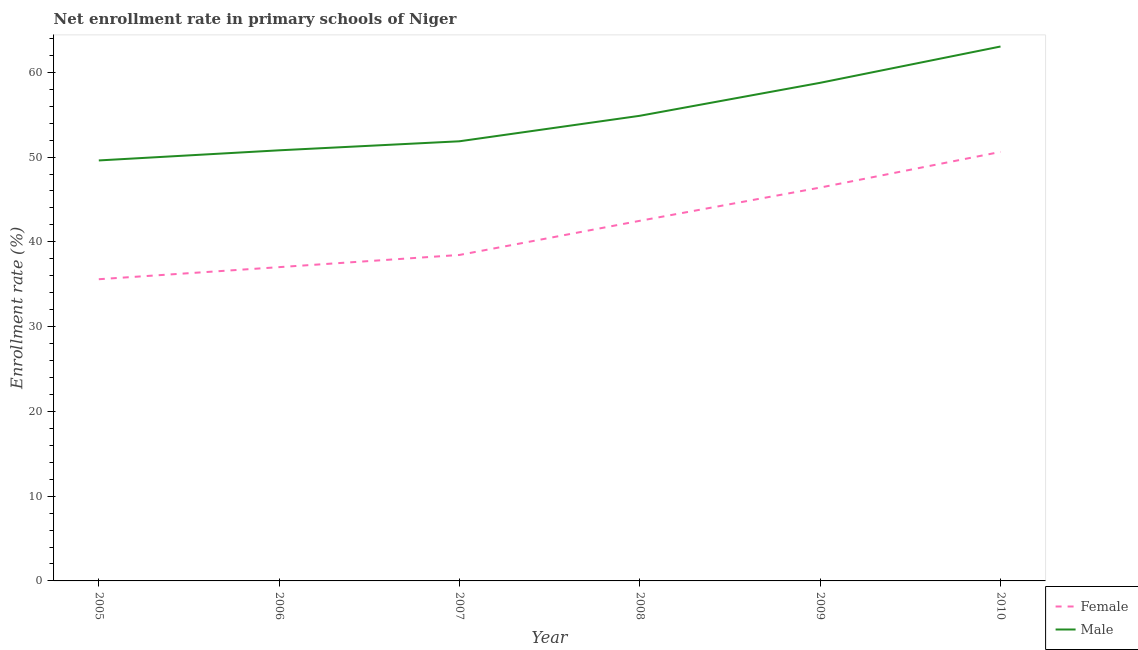What is the enrollment rate of female students in 2006?
Provide a short and direct response. 37.02. Across all years, what is the maximum enrollment rate of male students?
Ensure brevity in your answer.  63.04. Across all years, what is the minimum enrollment rate of male students?
Your answer should be compact. 49.6. What is the total enrollment rate of male students in the graph?
Make the answer very short. 328.95. What is the difference between the enrollment rate of female students in 2005 and that in 2007?
Your answer should be compact. -2.86. What is the difference between the enrollment rate of male students in 2007 and the enrollment rate of female students in 2010?
Keep it short and to the point. 1.25. What is the average enrollment rate of male students per year?
Provide a succinct answer. 54.82. In the year 2006, what is the difference between the enrollment rate of male students and enrollment rate of female students?
Ensure brevity in your answer.  13.78. What is the ratio of the enrollment rate of male students in 2006 to that in 2010?
Ensure brevity in your answer.  0.81. Is the enrollment rate of male students in 2005 less than that in 2010?
Make the answer very short. Yes. What is the difference between the highest and the second highest enrollment rate of female students?
Offer a terse response. 4.21. What is the difference between the highest and the lowest enrollment rate of female students?
Ensure brevity in your answer.  15.02. In how many years, is the enrollment rate of female students greater than the average enrollment rate of female students taken over all years?
Your answer should be very brief. 3. Is the sum of the enrollment rate of male students in 2006 and 2008 greater than the maximum enrollment rate of female students across all years?
Make the answer very short. Yes. Does the enrollment rate of female students monotonically increase over the years?
Your response must be concise. Yes. Is the enrollment rate of male students strictly greater than the enrollment rate of female students over the years?
Offer a terse response. Yes. How many lines are there?
Provide a short and direct response. 2. What is the difference between two consecutive major ticks on the Y-axis?
Your answer should be compact. 10. Does the graph contain any zero values?
Keep it short and to the point. No. Does the graph contain grids?
Provide a short and direct response. No. What is the title of the graph?
Your answer should be very brief. Net enrollment rate in primary schools of Niger. What is the label or title of the X-axis?
Keep it short and to the point. Year. What is the label or title of the Y-axis?
Provide a short and direct response. Enrollment rate (%). What is the Enrollment rate (%) of Female in 2005?
Your answer should be compact. 35.59. What is the Enrollment rate (%) of Male in 2005?
Your answer should be compact. 49.6. What is the Enrollment rate (%) in Female in 2006?
Provide a short and direct response. 37.02. What is the Enrollment rate (%) of Male in 2006?
Your response must be concise. 50.8. What is the Enrollment rate (%) in Female in 2007?
Offer a very short reply. 38.46. What is the Enrollment rate (%) of Male in 2007?
Provide a short and direct response. 51.87. What is the Enrollment rate (%) of Female in 2008?
Offer a terse response. 42.48. What is the Enrollment rate (%) of Male in 2008?
Offer a very short reply. 54.87. What is the Enrollment rate (%) of Female in 2009?
Your response must be concise. 46.4. What is the Enrollment rate (%) in Male in 2009?
Ensure brevity in your answer.  58.76. What is the Enrollment rate (%) of Female in 2010?
Provide a short and direct response. 50.61. What is the Enrollment rate (%) of Male in 2010?
Your answer should be very brief. 63.04. Across all years, what is the maximum Enrollment rate (%) in Female?
Offer a very short reply. 50.61. Across all years, what is the maximum Enrollment rate (%) of Male?
Provide a succinct answer. 63.04. Across all years, what is the minimum Enrollment rate (%) of Female?
Offer a very short reply. 35.59. Across all years, what is the minimum Enrollment rate (%) in Male?
Provide a succinct answer. 49.6. What is the total Enrollment rate (%) in Female in the graph?
Provide a short and direct response. 250.56. What is the total Enrollment rate (%) of Male in the graph?
Keep it short and to the point. 328.95. What is the difference between the Enrollment rate (%) of Female in 2005 and that in 2006?
Ensure brevity in your answer.  -1.43. What is the difference between the Enrollment rate (%) of Male in 2005 and that in 2006?
Offer a very short reply. -1.19. What is the difference between the Enrollment rate (%) in Female in 2005 and that in 2007?
Provide a succinct answer. -2.86. What is the difference between the Enrollment rate (%) of Male in 2005 and that in 2007?
Ensure brevity in your answer.  -2.26. What is the difference between the Enrollment rate (%) in Female in 2005 and that in 2008?
Your answer should be compact. -6.89. What is the difference between the Enrollment rate (%) in Male in 2005 and that in 2008?
Offer a terse response. -5.27. What is the difference between the Enrollment rate (%) of Female in 2005 and that in 2009?
Ensure brevity in your answer.  -10.81. What is the difference between the Enrollment rate (%) in Male in 2005 and that in 2009?
Your answer should be compact. -9.16. What is the difference between the Enrollment rate (%) in Female in 2005 and that in 2010?
Offer a very short reply. -15.02. What is the difference between the Enrollment rate (%) of Male in 2005 and that in 2010?
Give a very brief answer. -13.44. What is the difference between the Enrollment rate (%) of Female in 2006 and that in 2007?
Your response must be concise. -1.44. What is the difference between the Enrollment rate (%) in Male in 2006 and that in 2007?
Keep it short and to the point. -1.07. What is the difference between the Enrollment rate (%) of Female in 2006 and that in 2008?
Offer a terse response. -5.47. What is the difference between the Enrollment rate (%) of Male in 2006 and that in 2008?
Provide a short and direct response. -4.07. What is the difference between the Enrollment rate (%) of Female in 2006 and that in 2009?
Your answer should be compact. -9.39. What is the difference between the Enrollment rate (%) in Male in 2006 and that in 2009?
Your answer should be very brief. -7.96. What is the difference between the Enrollment rate (%) in Female in 2006 and that in 2010?
Provide a succinct answer. -13.59. What is the difference between the Enrollment rate (%) of Male in 2006 and that in 2010?
Offer a terse response. -12.25. What is the difference between the Enrollment rate (%) of Female in 2007 and that in 2008?
Offer a very short reply. -4.03. What is the difference between the Enrollment rate (%) of Male in 2007 and that in 2008?
Offer a terse response. -3.01. What is the difference between the Enrollment rate (%) in Female in 2007 and that in 2009?
Provide a succinct answer. -7.95. What is the difference between the Enrollment rate (%) in Male in 2007 and that in 2009?
Provide a succinct answer. -6.9. What is the difference between the Enrollment rate (%) in Female in 2007 and that in 2010?
Offer a terse response. -12.16. What is the difference between the Enrollment rate (%) of Male in 2007 and that in 2010?
Make the answer very short. -11.18. What is the difference between the Enrollment rate (%) of Female in 2008 and that in 2009?
Ensure brevity in your answer.  -3.92. What is the difference between the Enrollment rate (%) of Male in 2008 and that in 2009?
Your answer should be very brief. -3.89. What is the difference between the Enrollment rate (%) in Female in 2008 and that in 2010?
Make the answer very short. -8.13. What is the difference between the Enrollment rate (%) of Male in 2008 and that in 2010?
Offer a terse response. -8.17. What is the difference between the Enrollment rate (%) in Female in 2009 and that in 2010?
Make the answer very short. -4.21. What is the difference between the Enrollment rate (%) in Male in 2009 and that in 2010?
Keep it short and to the point. -4.28. What is the difference between the Enrollment rate (%) in Female in 2005 and the Enrollment rate (%) in Male in 2006?
Your response must be concise. -15.21. What is the difference between the Enrollment rate (%) in Female in 2005 and the Enrollment rate (%) in Male in 2007?
Provide a succinct answer. -16.27. What is the difference between the Enrollment rate (%) in Female in 2005 and the Enrollment rate (%) in Male in 2008?
Make the answer very short. -19.28. What is the difference between the Enrollment rate (%) of Female in 2005 and the Enrollment rate (%) of Male in 2009?
Your answer should be very brief. -23.17. What is the difference between the Enrollment rate (%) in Female in 2005 and the Enrollment rate (%) in Male in 2010?
Provide a short and direct response. -27.45. What is the difference between the Enrollment rate (%) of Female in 2006 and the Enrollment rate (%) of Male in 2007?
Offer a very short reply. -14.85. What is the difference between the Enrollment rate (%) in Female in 2006 and the Enrollment rate (%) in Male in 2008?
Offer a terse response. -17.86. What is the difference between the Enrollment rate (%) of Female in 2006 and the Enrollment rate (%) of Male in 2009?
Provide a succinct answer. -21.74. What is the difference between the Enrollment rate (%) in Female in 2006 and the Enrollment rate (%) in Male in 2010?
Provide a short and direct response. -26.03. What is the difference between the Enrollment rate (%) in Female in 2007 and the Enrollment rate (%) in Male in 2008?
Keep it short and to the point. -16.42. What is the difference between the Enrollment rate (%) of Female in 2007 and the Enrollment rate (%) of Male in 2009?
Offer a terse response. -20.31. What is the difference between the Enrollment rate (%) of Female in 2007 and the Enrollment rate (%) of Male in 2010?
Your answer should be compact. -24.59. What is the difference between the Enrollment rate (%) in Female in 2008 and the Enrollment rate (%) in Male in 2009?
Keep it short and to the point. -16.28. What is the difference between the Enrollment rate (%) of Female in 2008 and the Enrollment rate (%) of Male in 2010?
Keep it short and to the point. -20.56. What is the difference between the Enrollment rate (%) in Female in 2009 and the Enrollment rate (%) in Male in 2010?
Provide a short and direct response. -16.64. What is the average Enrollment rate (%) in Female per year?
Make the answer very short. 41.76. What is the average Enrollment rate (%) in Male per year?
Offer a terse response. 54.82. In the year 2005, what is the difference between the Enrollment rate (%) of Female and Enrollment rate (%) of Male?
Your answer should be compact. -14.01. In the year 2006, what is the difference between the Enrollment rate (%) of Female and Enrollment rate (%) of Male?
Ensure brevity in your answer.  -13.78. In the year 2007, what is the difference between the Enrollment rate (%) of Female and Enrollment rate (%) of Male?
Offer a very short reply. -13.41. In the year 2008, what is the difference between the Enrollment rate (%) in Female and Enrollment rate (%) in Male?
Give a very brief answer. -12.39. In the year 2009, what is the difference between the Enrollment rate (%) of Female and Enrollment rate (%) of Male?
Give a very brief answer. -12.36. In the year 2010, what is the difference between the Enrollment rate (%) of Female and Enrollment rate (%) of Male?
Give a very brief answer. -12.43. What is the ratio of the Enrollment rate (%) in Female in 2005 to that in 2006?
Your answer should be very brief. 0.96. What is the ratio of the Enrollment rate (%) in Male in 2005 to that in 2006?
Your response must be concise. 0.98. What is the ratio of the Enrollment rate (%) of Female in 2005 to that in 2007?
Your answer should be very brief. 0.93. What is the ratio of the Enrollment rate (%) in Male in 2005 to that in 2007?
Make the answer very short. 0.96. What is the ratio of the Enrollment rate (%) in Female in 2005 to that in 2008?
Give a very brief answer. 0.84. What is the ratio of the Enrollment rate (%) of Male in 2005 to that in 2008?
Give a very brief answer. 0.9. What is the ratio of the Enrollment rate (%) in Female in 2005 to that in 2009?
Ensure brevity in your answer.  0.77. What is the ratio of the Enrollment rate (%) in Male in 2005 to that in 2009?
Give a very brief answer. 0.84. What is the ratio of the Enrollment rate (%) in Female in 2005 to that in 2010?
Give a very brief answer. 0.7. What is the ratio of the Enrollment rate (%) in Male in 2005 to that in 2010?
Your answer should be very brief. 0.79. What is the ratio of the Enrollment rate (%) in Female in 2006 to that in 2007?
Your response must be concise. 0.96. What is the ratio of the Enrollment rate (%) of Male in 2006 to that in 2007?
Your answer should be very brief. 0.98. What is the ratio of the Enrollment rate (%) of Female in 2006 to that in 2008?
Provide a short and direct response. 0.87. What is the ratio of the Enrollment rate (%) of Male in 2006 to that in 2008?
Your response must be concise. 0.93. What is the ratio of the Enrollment rate (%) in Female in 2006 to that in 2009?
Make the answer very short. 0.8. What is the ratio of the Enrollment rate (%) in Male in 2006 to that in 2009?
Make the answer very short. 0.86. What is the ratio of the Enrollment rate (%) in Female in 2006 to that in 2010?
Give a very brief answer. 0.73. What is the ratio of the Enrollment rate (%) in Male in 2006 to that in 2010?
Your answer should be very brief. 0.81. What is the ratio of the Enrollment rate (%) of Female in 2007 to that in 2008?
Offer a terse response. 0.91. What is the ratio of the Enrollment rate (%) of Male in 2007 to that in 2008?
Provide a succinct answer. 0.95. What is the ratio of the Enrollment rate (%) in Female in 2007 to that in 2009?
Offer a terse response. 0.83. What is the ratio of the Enrollment rate (%) in Male in 2007 to that in 2009?
Provide a short and direct response. 0.88. What is the ratio of the Enrollment rate (%) in Female in 2007 to that in 2010?
Offer a very short reply. 0.76. What is the ratio of the Enrollment rate (%) of Male in 2007 to that in 2010?
Your response must be concise. 0.82. What is the ratio of the Enrollment rate (%) in Female in 2008 to that in 2009?
Provide a short and direct response. 0.92. What is the ratio of the Enrollment rate (%) in Male in 2008 to that in 2009?
Offer a terse response. 0.93. What is the ratio of the Enrollment rate (%) in Female in 2008 to that in 2010?
Make the answer very short. 0.84. What is the ratio of the Enrollment rate (%) in Male in 2008 to that in 2010?
Give a very brief answer. 0.87. What is the ratio of the Enrollment rate (%) of Female in 2009 to that in 2010?
Your response must be concise. 0.92. What is the ratio of the Enrollment rate (%) in Male in 2009 to that in 2010?
Your response must be concise. 0.93. What is the difference between the highest and the second highest Enrollment rate (%) in Female?
Your response must be concise. 4.21. What is the difference between the highest and the second highest Enrollment rate (%) in Male?
Provide a short and direct response. 4.28. What is the difference between the highest and the lowest Enrollment rate (%) in Female?
Give a very brief answer. 15.02. What is the difference between the highest and the lowest Enrollment rate (%) in Male?
Offer a terse response. 13.44. 